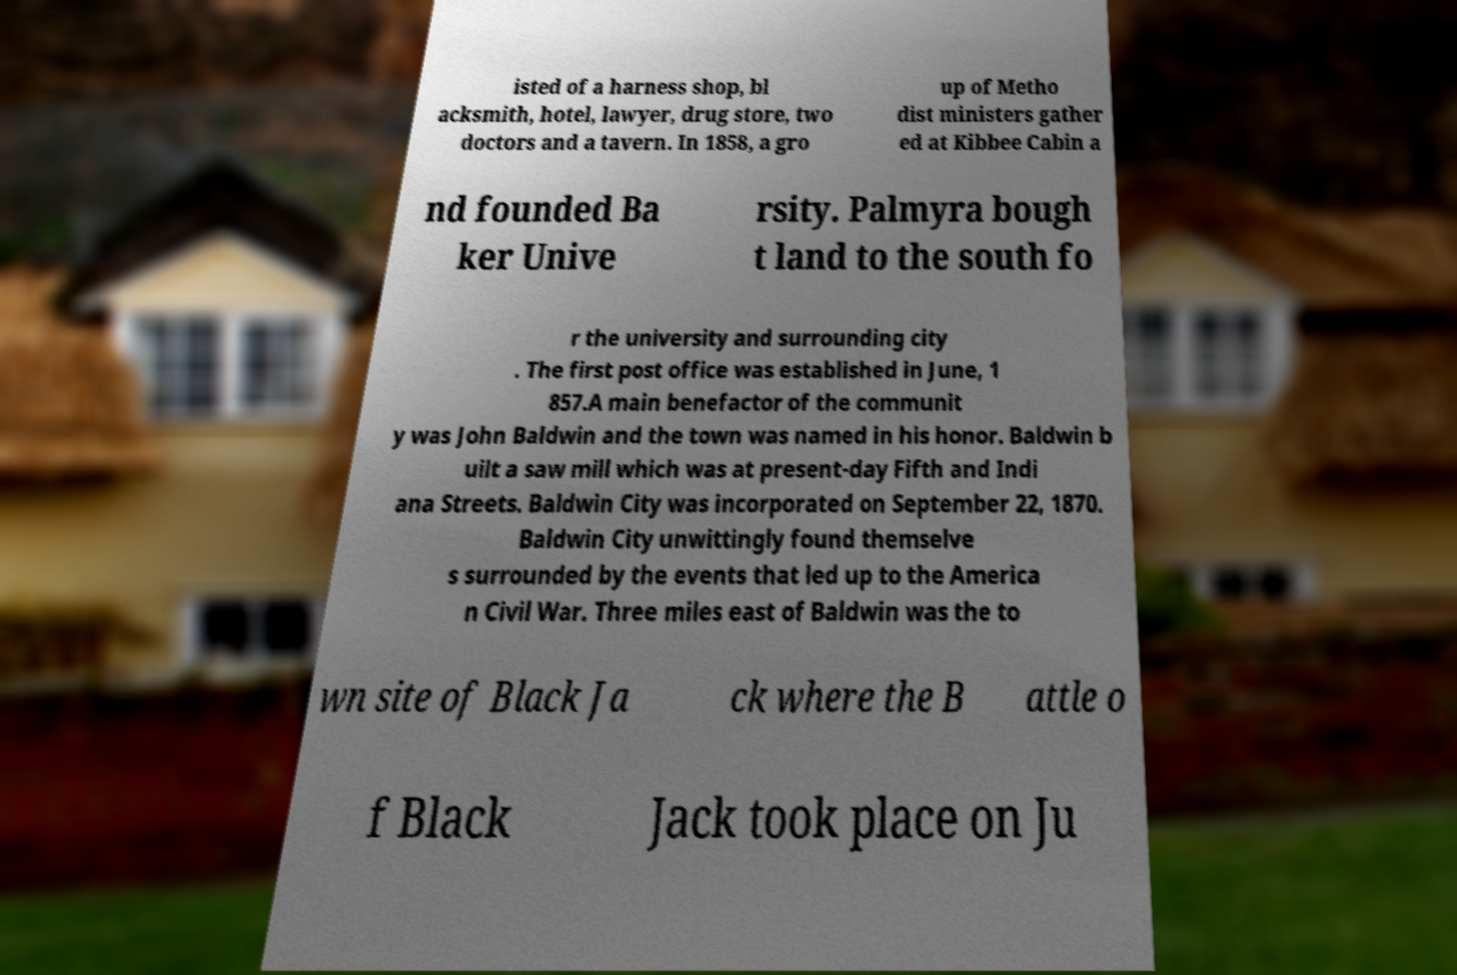I need the written content from this picture converted into text. Can you do that? isted of a harness shop, bl acksmith, hotel, lawyer, drug store, two doctors and a tavern. In 1858, a gro up of Metho dist ministers gather ed at Kibbee Cabin a nd founded Ba ker Unive rsity. Palmyra bough t land to the south fo r the university and surrounding city . The first post office was established in June, 1 857.A main benefactor of the communit y was John Baldwin and the town was named in his honor. Baldwin b uilt a saw mill which was at present-day Fifth and Indi ana Streets. Baldwin City was incorporated on September 22, 1870. Baldwin City unwittingly found themselve s surrounded by the events that led up to the America n Civil War. Three miles east of Baldwin was the to wn site of Black Ja ck where the B attle o f Black Jack took place on Ju 